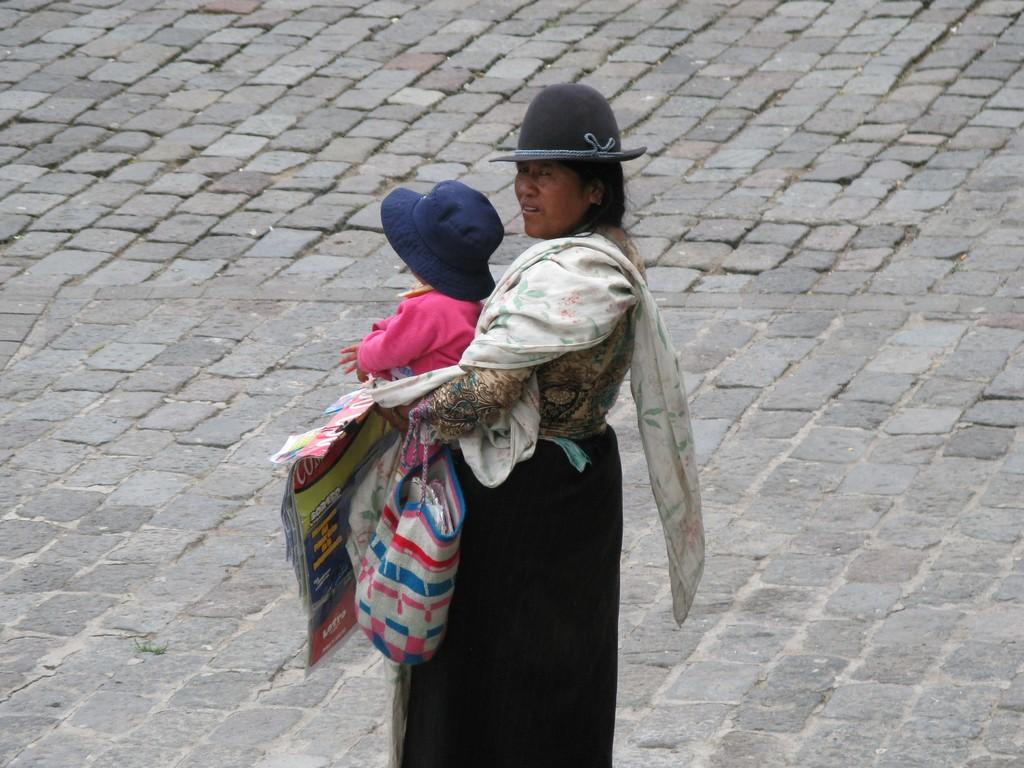Who is the main subject in the image? There is a lady in the image. What is the lady holding in the image? The lady is holding a baby and a bag. Where is the lady standing in the image? The lady is standing on a road. What type of alarm can be heard in the image? There is no alarm present in the image; it is a still image of a lady holding a baby and a bag while standing on a road. 